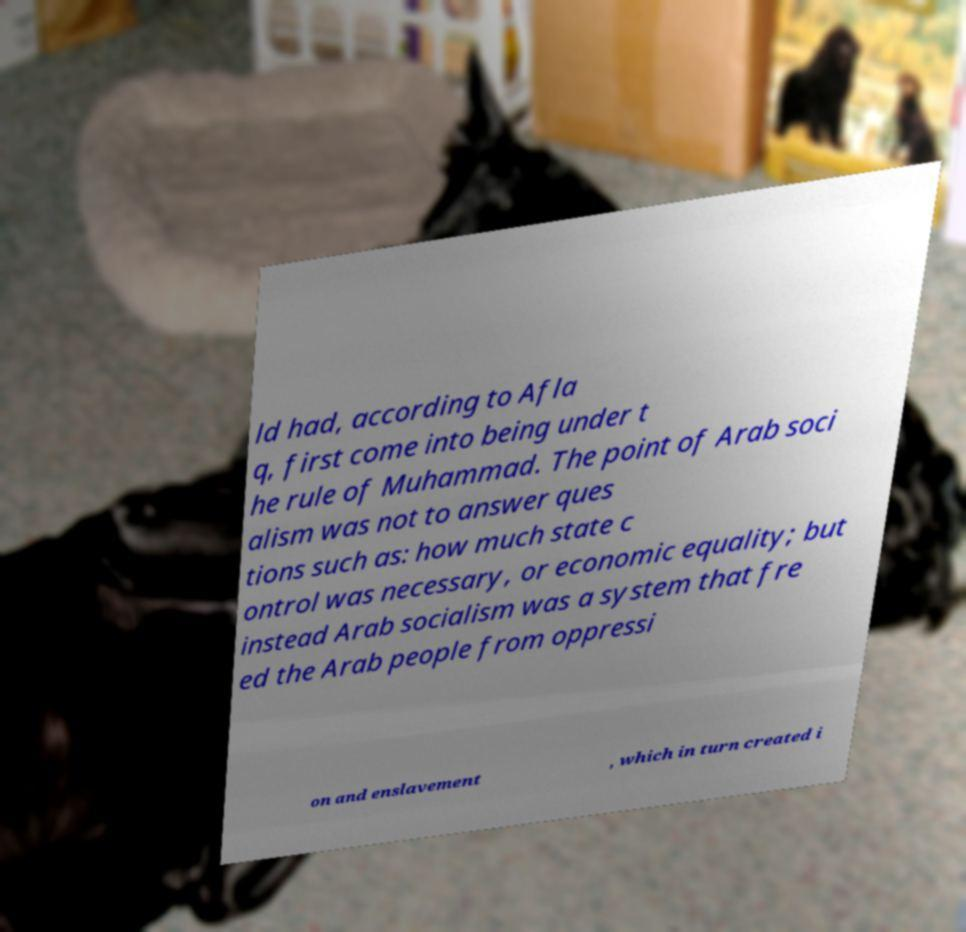For documentation purposes, I need the text within this image transcribed. Could you provide that? ld had, according to Afla q, first come into being under t he rule of Muhammad. The point of Arab soci alism was not to answer ques tions such as: how much state c ontrol was necessary, or economic equality; but instead Arab socialism was a system that fre ed the Arab people from oppressi on and enslavement , which in turn created i 